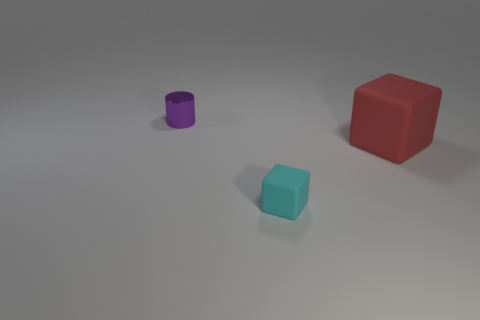Subtract all cubes. How many objects are left? 1 Subtract 2 cubes. How many cubes are left? 0 Subtract all blue cylinders. Subtract all blue blocks. How many cylinders are left? 1 Subtract all green cylinders. How many red cubes are left? 1 Subtract all purple cylinders. Subtract all red matte objects. How many objects are left? 1 Add 1 big red matte objects. How many big red matte objects are left? 2 Add 2 cylinders. How many cylinders exist? 3 Add 2 big shiny things. How many objects exist? 5 Subtract 0 yellow cylinders. How many objects are left? 3 